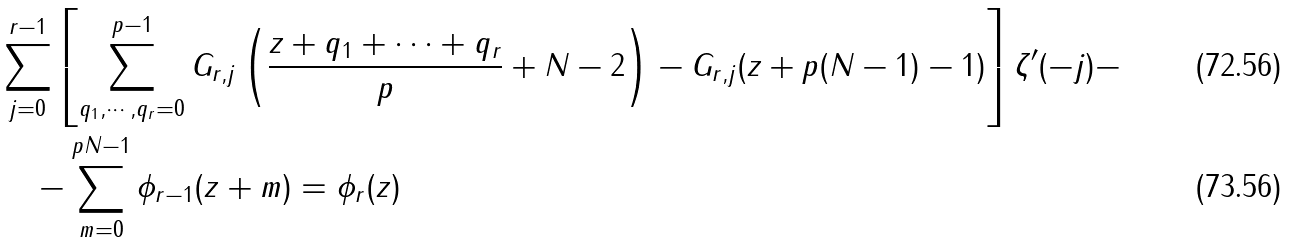Convert formula to latex. <formula><loc_0><loc_0><loc_500><loc_500>& \sum _ { j = 0 } ^ { r - 1 } \left [ \sum _ { q _ { 1 } , \cdots , q _ { r } = 0 } ^ { p - 1 } G _ { r , j } \left ( \frac { z + q _ { 1 } + \cdots + q _ { r } } p + N - 2 \right ) - G _ { r , j } ( z + p ( N - 1 ) - 1 ) \right ] \zeta ^ { \prime } ( - j ) - \\ & \quad - \sum _ { m = 0 } ^ { p N - 1 } \phi _ { r - 1 } ( z + m ) = \phi _ { r } ( z )</formula> 